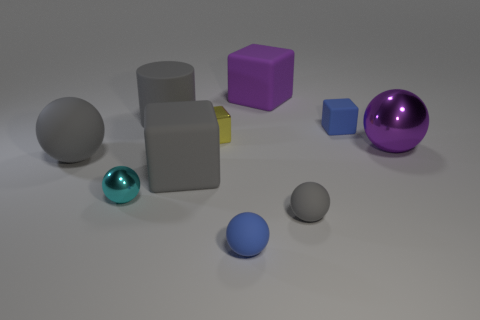What number of objects are either shiny spheres that are left of the small gray sphere or blue objects that are to the left of the blue cube?
Ensure brevity in your answer.  2. Does the matte cylinder have the same size as the shiny sphere that is right of the tiny blue matte sphere?
Your answer should be very brief. Yes. Do the big sphere on the left side of the gray rubber block and the gray ball right of the cyan shiny sphere have the same material?
Keep it short and to the point. Yes. Are there an equal number of big purple metal spheres that are in front of the big gray ball and shiny spheres that are behind the tiny yellow shiny cube?
Make the answer very short. Yes. What number of large matte things are the same color as the big metal ball?
Keep it short and to the point. 1. There is a large block that is the same color as the large metal ball; what is it made of?
Give a very brief answer. Rubber. How many metal things are either small spheres or big spheres?
Make the answer very short. 2. There is a purple shiny thing that is right of the purple rubber block; is its shape the same as the rubber object that is left of the small cyan ball?
Offer a very short reply. Yes. There is a large rubber cylinder; what number of big gray objects are in front of it?
Your response must be concise. 2. Are there any large cubes made of the same material as the big gray sphere?
Provide a succinct answer. Yes. 